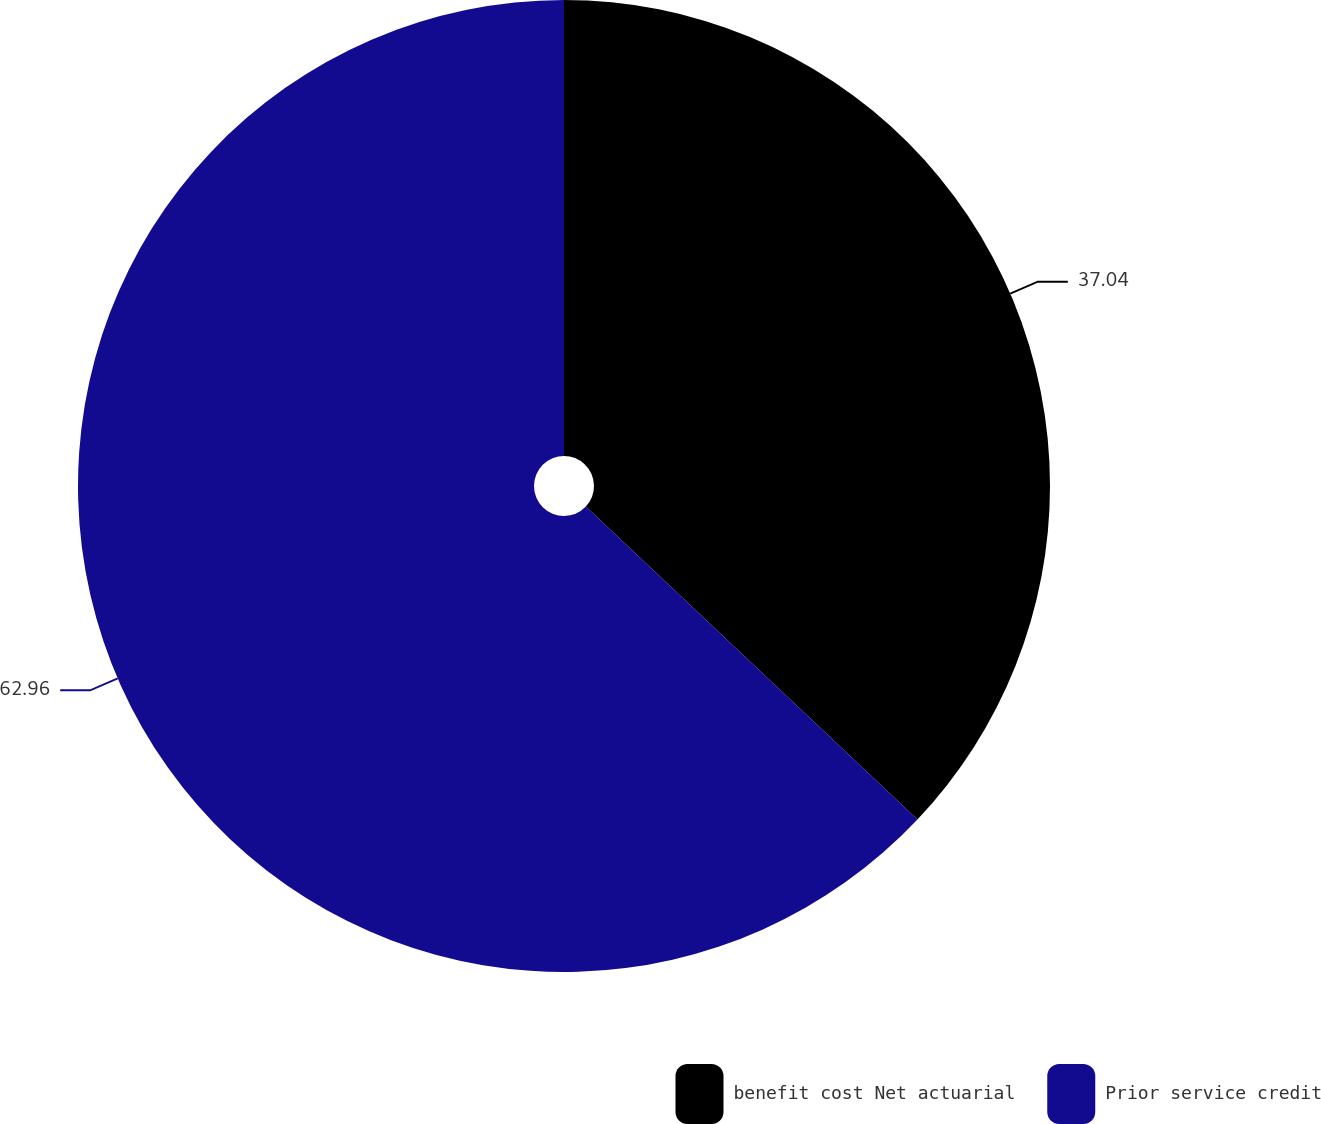Convert chart to OTSL. <chart><loc_0><loc_0><loc_500><loc_500><pie_chart><fcel>benefit cost Net actuarial<fcel>Prior service credit<nl><fcel>37.04%<fcel>62.96%<nl></chart> 